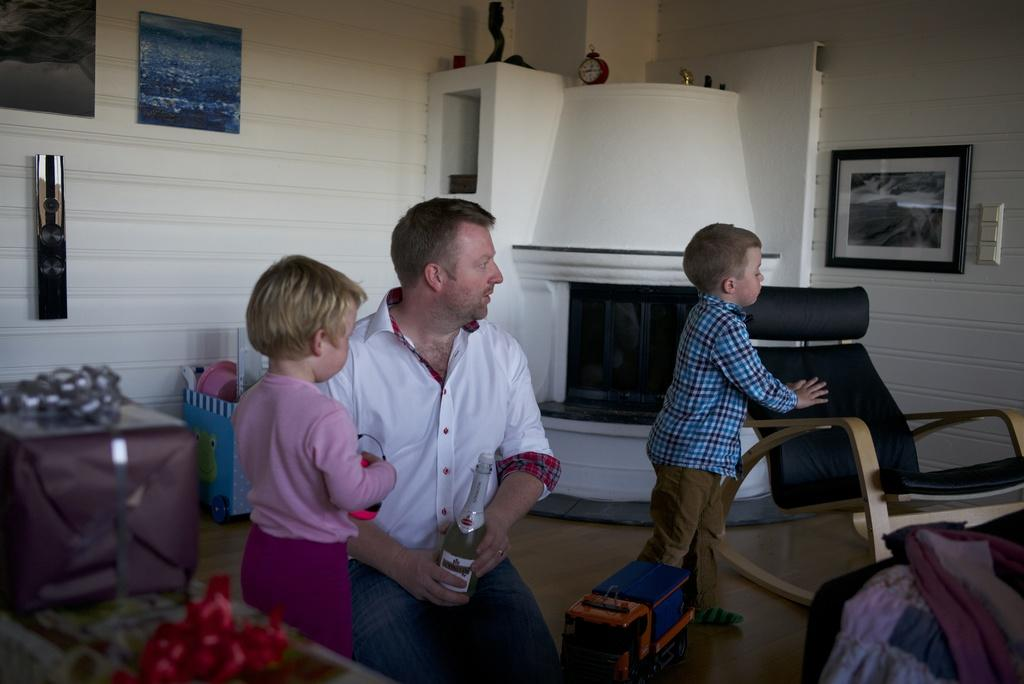What is the man doing in the image? There is a man sitting in the image. How many children are in the image? There are two children standing in the image. Where are the children located in the image? The children are standing on the right side of the image. What can be seen in the background of the image? There is a chair and a wall in the background of the image. What is attached to the wall in the background of the image? There is a frame attached to the wall in the background of the image. What type of lettuce is being served on the cake in the image? There is no cake or lettuce present in the image. How many shoes are visible on the children's feet in the image? The image does not show the children's feet, so it is not possible to determine how many shoes they are wearing. 